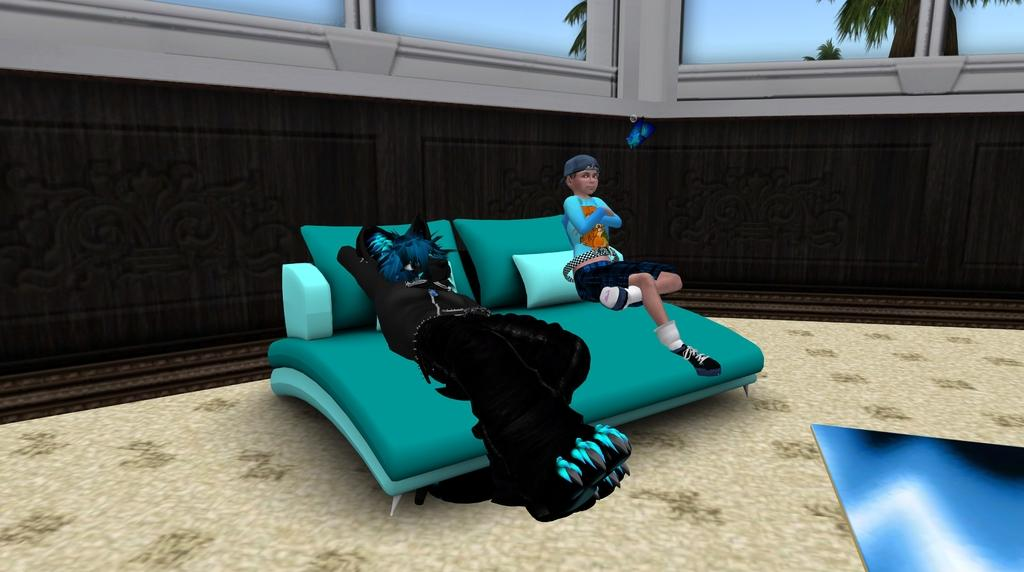What type of image is this? The image is animated. What piece of furniture is on the floor? There is a sofa on the floor. Who or what is sitting on the sofa? A person and a cat are sitting on the sofa. What can be seen in the background of the image? There is a wall and glass doors in the background. How much wealth is displayed in the image? There is no indication of wealth in the image; it features a sofa, a person, a cat, and a background with a wall and glass doors. Is there a battle taking place in the image? No, there is no battle depicted in the image. 